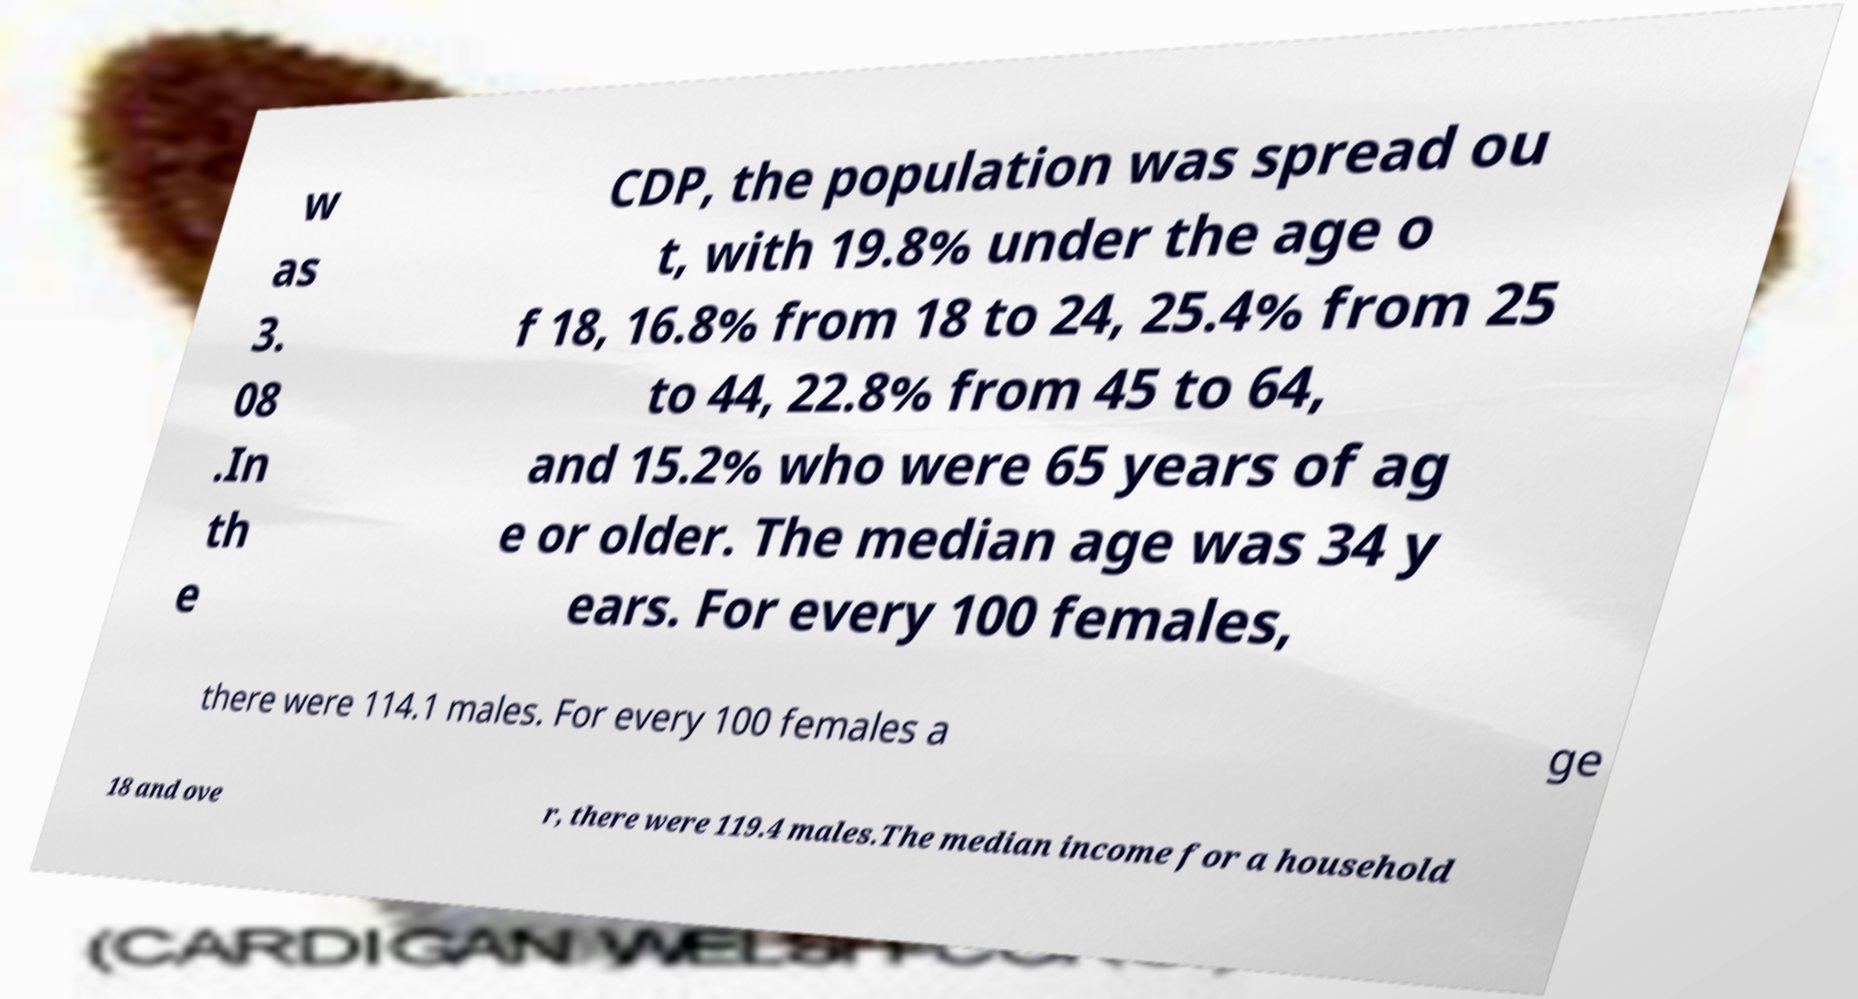For documentation purposes, I need the text within this image transcribed. Could you provide that? w as 3. 08 .In th e CDP, the population was spread ou t, with 19.8% under the age o f 18, 16.8% from 18 to 24, 25.4% from 25 to 44, 22.8% from 45 to 64, and 15.2% who were 65 years of ag e or older. The median age was 34 y ears. For every 100 females, there were 114.1 males. For every 100 females a ge 18 and ove r, there were 119.4 males.The median income for a household 